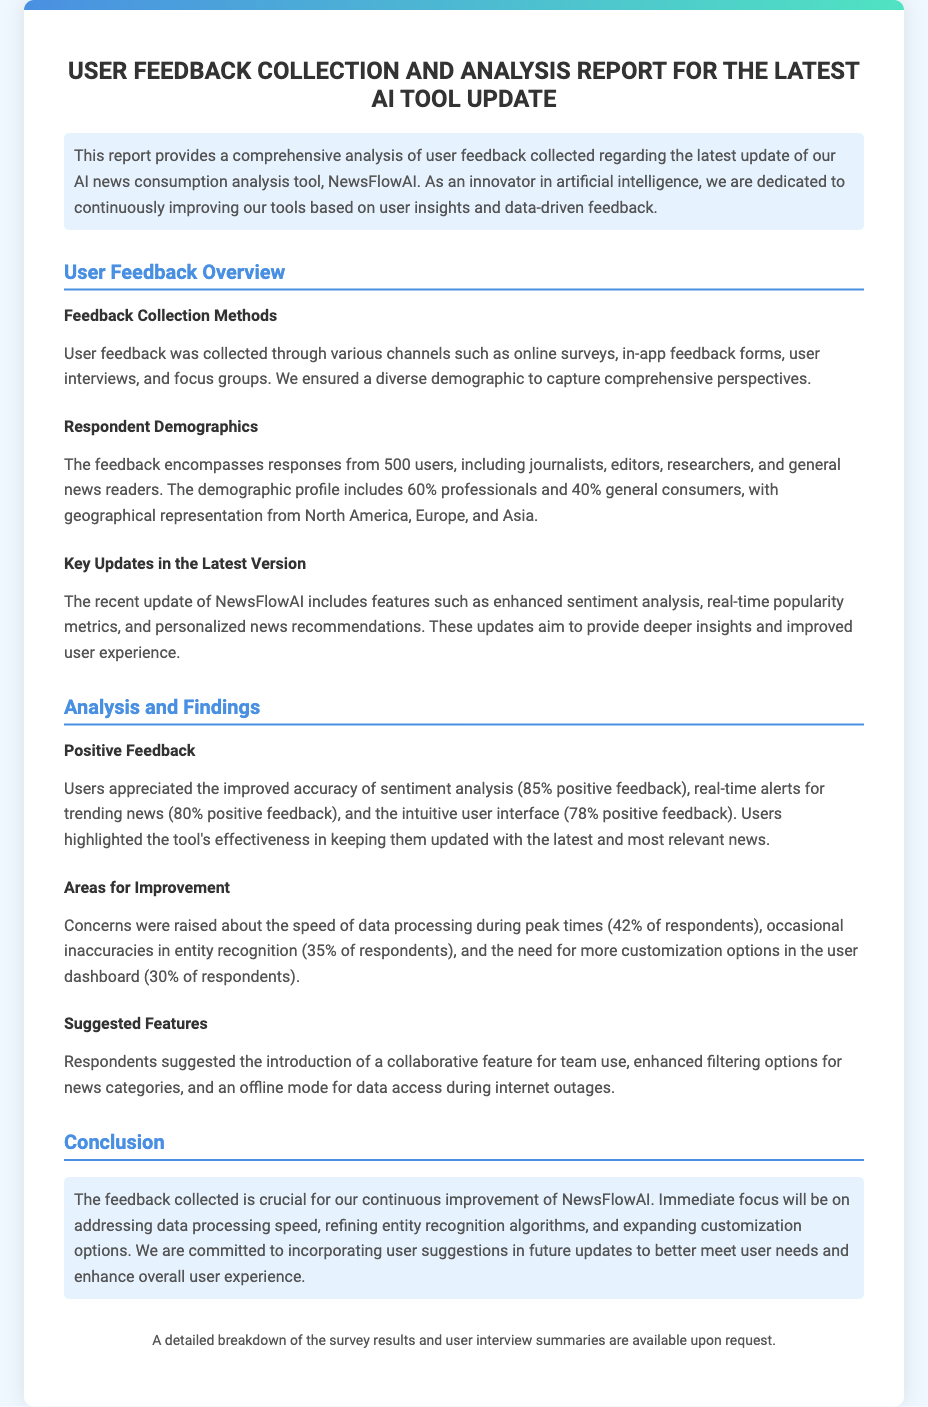What is the title of the report? The title of the report is mentioned at the top of the document as "User Feedback Collection and Analysis Report for the Latest AI Tool Update."
Answer: User Feedback Collection and Analysis Report for the Latest AI Tool Update How many users provided feedback? The document states that feedback was collected from a total of 500 users.
Answer: 500 users What percentage of respondents raised concerns about data processing speed? The document indicates that 42% of respondents reported concerns about the speed of data processing during peak times.
Answer: 42% What feature did 85% of users appreciate? The report mentions that 85% of users appreciated the improved accuracy of sentiment analysis.
Answer: Improved accuracy of sentiment analysis What geographical regions are represented in the feedback? The document lists North America, Europe, and Asia as the geographical representation of respondents.
Answer: North America, Europe, and Asia What is a suggested feature from the respondents? The document states that respondents suggested the introduction of a collaborative feature for team use as one of the new features.
Answer: Collaborative feature for team use What is the percentage of positive feedback for real-time alerts? The report states that 80% of users provided positive feedback for real-time alerts for trending news.
Answer: 80% What aspect of the user experience is the immediate focus for improvement? The document specifies that there will be an immediate focus on addressing data processing speed.
Answer: Data processing speed 